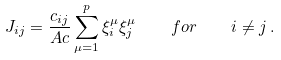Convert formula to latex. <formula><loc_0><loc_0><loc_500><loc_500>J _ { i j } = \frac { c _ { i j } } { A c } \sum _ { \mu = 1 } ^ { p } \xi _ { i } ^ { \mu } \xi _ { j } ^ { \mu } \quad f o r \quad i \not = j \, .</formula> 